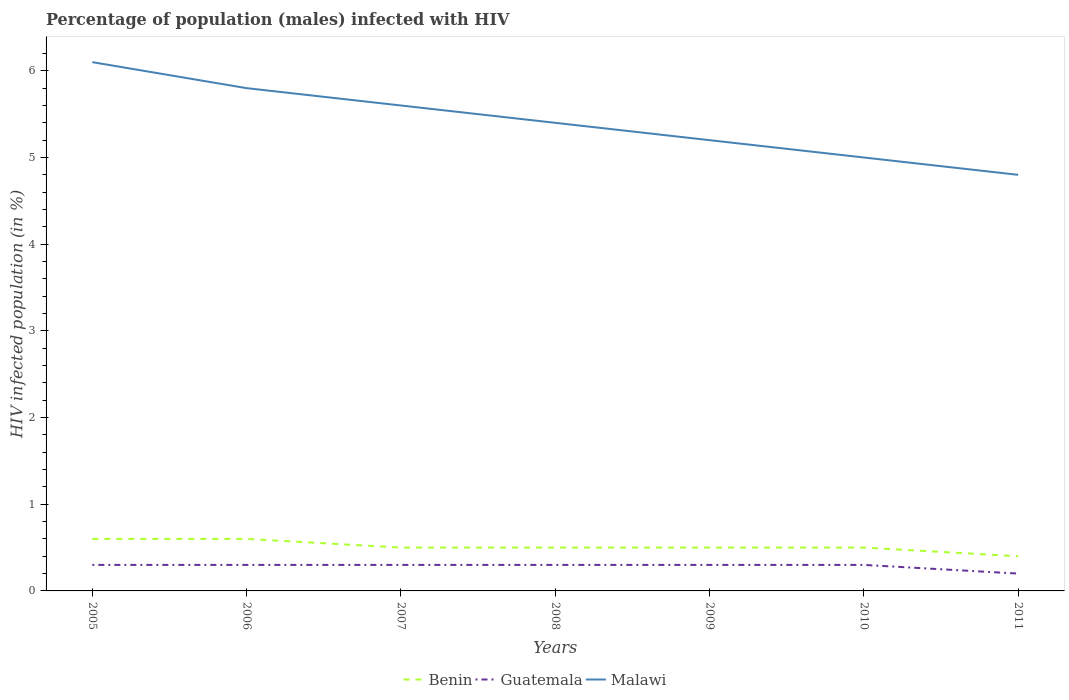How many different coloured lines are there?
Your answer should be very brief. 3. Does the line corresponding to Malawi intersect with the line corresponding to Guatemala?
Your response must be concise. No. Across all years, what is the maximum percentage of HIV infected male population in Malawi?
Keep it short and to the point. 4.8. In which year was the percentage of HIV infected male population in Guatemala maximum?
Provide a short and direct response. 2011. What is the total percentage of HIV infected male population in Benin in the graph?
Your answer should be compact. 0.1. What is the difference between the highest and the second highest percentage of HIV infected male population in Malawi?
Keep it short and to the point. 1.3. How many lines are there?
Keep it short and to the point. 3. How many years are there in the graph?
Your answer should be very brief. 7. How are the legend labels stacked?
Provide a succinct answer. Horizontal. What is the title of the graph?
Make the answer very short. Percentage of population (males) infected with HIV. Does "St. Vincent and the Grenadines" appear as one of the legend labels in the graph?
Provide a short and direct response. No. What is the label or title of the X-axis?
Keep it short and to the point. Years. What is the label or title of the Y-axis?
Give a very brief answer. HIV infected population (in %). What is the HIV infected population (in %) in Benin in 2005?
Offer a terse response. 0.6. What is the HIV infected population (in %) in Guatemala in 2005?
Your response must be concise. 0.3. What is the HIV infected population (in %) of Guatemala in 2006?
Provide a short and direct response. 0.3. What is the HIV infected population (in %) in Malawi in 2006?
Your answer should be compact. 5.8. What is the HIV infected population (in %) of Guatemala in 2007?
Your answer should be very brief. 0.3. What is the HIV infected population (in %) of Guatemala in 2008?
Your answer should be very brief. 0.3. What is the HIV infected population (in %) of Benin in 2009?
Make the answer very short. 0.5. What is the HIV infected population (in %) of Guatemala in 2009?
Make the answer very short. 0.3. What is the HIV infected population (in %) of Malawi in 2009?
Your answer should be very brief. 5.2. What is the HIV infected population (in %) of Benin in 2010?
Keep it short and to the point. 0.5. What is the HIV infected population (in %) in Benin in 2011?
Your answer should be very brief. 0.4. What is the HIV infected population (in %) in Guatemala in 2011?
Provide a succinct answer. 0.2. What is the HIV infected population (in %) in Malawi in 2011?
Offer a terse response. 4.8. Across all years, what is the maximum HIV infected population (in %) of Benin?
Your answer should be very brief. 0.6. Across all years, what is the maximum HIV infected population (in %) of Malawi?
Your answer should be compact. 6.1. Across all years, what is the minimum HIV infected population (in %) in Benin?
Your answer should be very brief. 0.4. Across all years, what is the minimum HIV infected population (in %) in Guatemala?
Offer a very short reply. 0.2. Across all years, what is the minimum HIV infected population (in %) of Malawi?
Your response must be concise. 4.8. What is the total HIV infected population (in %) in Malawi in the graph?
Ensure brevity in your answer.  37.9. What is the difference between the HIV infected population (in %) of Benin in 2005 and that in 2006?
Offer a terse response. 0. What is the difference between the HIV infected population (in %) in Malawi in 2005 and that in 2007?
Your response must be concise. 0.5. What is the difference between the HIV infected population (in %) in Malawi in 2005 and that in 2008?
Make the answer very short. 0.7. What is the difference between the HIV infected population (in %) of Benin in 2005 and that in 2009?
Offer a terse response. 0.1. What is the difference between the HIV infected population (in %) of Guatemala in 2005 and that in 2009?
Your response must be concise. 0. What is the difference between the HIV infected population (in %) in Malawi in 2005 and that in 2009?
Offer a very short reply. 0.9. What is the difference between the HIV infected population (in %) of Malawi in 2005 and that in 2010?
Provide a succinct answer. 1.1. What is the difference between the HIV infected population (in %) of Malawi in 2005 and that in 2011?
Offer a terse response. 1.3. What is the difference between the HIV infected population (in %) in Benin in 2006 and that in 2008?
Keep it short and to the point. 0.1. What is the difference between the HIV infected population (in %) of Guatemala in 2006 and that in 2008?
Give a very brief answer. 0. What is the difference between the HIV infected population (in %) in Malawi in 2006 and that in 2008?
Your response must be concise. 0.4. What is the difference between the HIV infected population (in %) of Benin in 2006 and that in 2009?
Provide a succinct answer. 0.1. What is the difference between the HIV infected population (in %) in Guatemala in 2006 and that in 2009?
Offer a terse response. 0. What is the difference between the HIV infected population (in %) of Malawi in 2006 and that in 2009?
Make the answer very short. 0.6. What is the difference between the HIV infected population (in %) in Benin in 2006 and that in 2010?
Give a very brief answer. 0.1. What is the difference between the HIV infected population (in %) in Guatemala in 2006 and that in 2010?
Your answer should be compact. 0. What is the difference between the HIV infected population (in %) in Malawi in 2006 and that in 2010?
Offer a terse response. 0.8. What is the difference between the HIV infected population (in %) in Benin in 2006 and that in 2011?
Your response must be concise. 0.2. What is the difference between the HIV infected population (in %) in Guatemala in 2006 and that in 2011?
Make the answer very short. 0.1. What is the difference between the HIV infected population (in %) of Benin in 2007 and that in 2008?
Your answer should be compact. 0. What is the difference between the HIV infected population (in %) of Malawi in 2007 and that in 2008?
Keep it short and to the point. 0.2. What is the difference between the HIV infected population (in %) of Benin in 2007 and that in 2009?
Ensure brevity in your answer.  0. What is the difference between the HIV infected population (in %) of Malawi in 2007 and that in 2009?
Provide a short and direct response. 0.4. What is the difference between the HIV infected population (in %) in Malawi in 2007 and that in 2010?
Provide a short and direct response. 0.6. What is the difference between the HIV infected population (in %) of Benin in 2007 and that in 2011?
Keep it short and to the point. 0.1. What is the difference between the HIV infected population (in %) in Malawi in 2007 and that in 2011?
Your answer should be very brief. 0.8. What is the difference between the HIV infected population (in %) in Benin in 2008 and that in 2009?
Your response must be concise. 0. What is the difference between the HIV infected population (in %) in Guatemala in 2008 and that in 2009?
Offer a very short reply. 0. What is the difference between the HIV infected population (in %) in Malawi in 2008 and that in 2009?
Give a very brief answer. 0.2. What is the difference between the HIV infected population (in %) of Benin in 2008 and that in 2010?
Your answer should be very brief. 0. What is the difference between the HIV infected population (in %) of Guatemala in 2008 and that in 2010?
Your answer should be very brief. 0. What is the difference between the HIV infected population (in %) in Benin in 2009 and that in 2011?
Your answer should be compact. 0.1. What is the difference between the HIV infected population (in %) in Guatemala in 2009 and that in 2011?
Your response must be concise. 0.1. What is the difference between the HIV infected population (in %) of Malawi in 2010 and that in 2011?
Offer a very short reply. 0.2. What is the difference between the HIV infected population (in %) of Guatemala in 2005 and the HIV infected population (in %) of Malawi in 2006?
Offer a terse response. -5.5. What is the difference between the HIV infected population (in %) of Guatemala in 2005 and the HIV infected population (in %) of Malawi in 2007?
Ensure brevity in your answer.  -5.3. What is the difference between the HIV infected population (in %) in Guatemala in 2005 and the HIV infected population (in %) in Malawi in 2008?
Give a very brief answer. -5.1. What is the difference between the HIV infected population (in %) in Benin in 2005 and the HIV infected population (in %) in Guatemala in 2009?
Provide a short and direct response. 0.3. What is the difference between the HIV infected population (in %) of Benin in 2005 and the HIV infected population (in %) of Malawi in 2009?
Your response must be concise. -4.6. What is the difference between the HIV infected population (in %) in Benin in 2005 and the HIV infected population (in %) in Guatemala in 2010?
Your answer should be very brief. 0.3. What is the difference between the HIV infected population (in %) in Guatemala in 2005 and the HIV infected population (in %) in Malawi in 2010?
Your response must be concise. -4.7. What is the difference between the HIV infected population (in %) in Benin in 2006 and the HIV infected population (in %) in Guatemala in 2007?
Offer a very short reply. 0.3. What is the difference between the HIV infected population (in %) of Benin in 2006 and the HIV infected population (in %) of Malawi in 2007?
Offer a very short reply. -5. What is the difference between the HIV infected population (in %) of Guatemala in 2006 and the HIV infected population (in %) of Malawi in 2007?
Ensure brevity in your answer.  -5.3. What is the difference between the HIV infected population (in %) in Benin in 2006 and the HIV infected population (in %) in Guatemala in 2008?
Your response must be concise. 0.3. What is the difference between the HIV infected population (in %) of Benin in 2006 and the HIV infected population (in %) of Guatemala in 2009?
Keep it short and to the point. 0.3. What is the difference between the HIV infected population (in %) of Benin in 2006 and the HIV infected population (in %) of Malawi in 2009?
Provide a succinct answer. -4.6. What is the difference between the HIV infected population (in %) in Guatemala in 2006 and the HIV infected population (in %) in Malawi in 2009?
Provide a short and direct response. -4.9. What is the difference between the HIV infected population (in %) of Benin in 2006 and the HIV infected population (in %) of Guatemala in 2010?
Provide a short and direct response. 0.3. What is the difference between the HIV infected population (in %) in Guatemala in 2006 and the HIV infected population (in %) in Malawi in 2010?
Your answer should be very brief. -4.7. What is the difference between the HIV infected population (in %) of Benin in 2006 and the HIV infected population (in %) of Guatemala in 2011?
Make the answer very short. 0.4. What is the difference between the HIV infected population (in %) of Benin in 2006 and the HIV infected population (in %) of Malawi in 2011?
Your answer should be compact. -4.2. What is the difference between the HIV infected population (in %) of Guatemala in 2006 and the HIV infected population (in %) of Malawi in 2011?
Make the answer very short. -4.5. What is the difference between the HIV infected population (in %) in Benin in 2007 and the HIV infected population (in %) in Guatemala in 2008?
Offer a terse response. 0.2. What is the difference between the HIV infected population (in %) in Benin in 2007 and the HIV infected population (in %) in Malawi in 2008?
Your answer should be compact. -4.9. What is the difference between the HIV infected population (in %) in Guatemala in 2007 and the HIV infected population (in %) in Malawi in 2008?
Provide a succinct answer. -5.1. What is the difference between the HIV infected population (in %) of Benin in 2007 and the HIV infected population (in %) of Guatemala in 2009?
Give a very brief answer. 0.2. What is the difference between the HIV infected population (in %) of Benin in 2007 and the HIV infected population (in %) of Malawi in 2009?
Give a very brief answer. -4.7. What is the difference between the HIV infected population (in %) in Guatemala in 2007 and the HIV infected population (in %) in Malawi in 2009?
Keep it short and to the point. -4.9. What is the difference between the HIV infected population (in %) of Benin in 2007 and the HIV infected population (in %) of Guatemala in 2010?
Keep it short and to the point. 0.2. What is the difference between the HIV infected population (in %) of Benin in 2007 and the HIV infected population (in %) of Malawi in 2010?
Keep it short and to the point. -4.5. What is the difference between the HIV infected population (in %) of Guatemala in 2007 and the HIV infected population (in %) of Malawi in 2010?
Your response must be concise. -4.7. What is the difference between the HIV infected population (in %) of Benin in 2007 and the HIV infected population (in %) of Guatemala in 2011?
Offer a very short reply. 0.3. What is the difference between the HIV infected population (in %) in Benin in 2007 and the HIV infected population (in %) in Malawi in 2011?
Ensure brevity in your answer.  -4.3. What is the difference between the HIV infected population (in %) of Benin in 2008 and the HIV infected population (in %) of Guatemala in 2009?
Provide a short and direct response. 0.2. What is the difference between the HIV infected population (in %) in Guatemala in 2008 and the HIV infected population (in %) in Malawi in 2010?
Offer a terse response. -4.7. What is the difference between the HIV infected population (in %) of Benin in 2008 and the HIV infected population (in %) of Malawi in 2011?
Offer a very short reply. -4.3. What is the difference between the HIV infected population (in %) in Guatemala in 2008 and the HIV infected population (in %) in Malawi in 2011?
Your answer should be very brief. -4.5. What is the difference between the HIV infected population (in %) in Benin in 2009 and the HIV infected population (in %) in Malawi in 2010?
Your answer should be compact. -4.5. What is the difference between the HIV infected population (in %) in Guatemala in 2009 and the HIV infected population (in %) in Malawi in 2010?
Keep it short and to the point. -4.7. What is the difference between the HIV infected population (in %) in Guatemala in 2009 and the HIV infected population (in %) in Malawi in 2011?
Provide a short and direct response. -4.5. What is the difference between the HIV infected population (in %) in Guatemala in 2010 and the HIV infected population (in %) in Malawi in 2011?
Provide a succinct answer. -4.5. What is the average HIV infected population (in %) of Benin per year?
Ensure brevity in your answer.  0.51. What is the average HIV infected population (in %) in Guatemala per year?
Make the answer very short. 0.29. What is the average HIV infected population (in %) of Malawi per year?
Ensure brevity in your answer.  5.41. In the year 2005, what is the difference between the HIV infected population (in %) in Benin and HIV infected population (in %) in Guatemala?
Offer a very short reply. 0.3. In the year 2005, what is the difference between the HIV infected population (in %) in Benin and HIV infected population (in %) in Malawi?
Offer a terse response. -5.5. In the year 2005, what is the difference between the HIV infected population (in %) of Guatemala and HIV infected population (in %) of Malawi?
Provide a short and direct response. -5.8. In the year 2006, what is the difference between the HIV infected population (in %) in Guatemala and HIV infected population (in %) in Malawi?
Offer a terse response. -5.5. In the year 2007, what is the difference between the HIV infected population (in %) in Guatemala and HIV infected population (in %) in Malawi?
Keep it short and to the point. -5.3. In the year 2008, what is the difference between the HIV infected population (in %) of Benin and HIV infected population (in %) of Guatemala?
Your answer should be very brief. 0.2. In the year 2008, what is the difference between the HIV infected population (in %) of Benin and HIV infected population (in %) of Malawi?
Your answer should be very brief. -4.9. In the year 2009, what is the difference between the HIV infected population (in %) in Benin and HIV infected population (in %) in Guatemala?
Provide a succinct answer. 0.2. In the year 2009, what is the difference between the HIV infected population (in %) of Guatemala and HIV infected population (in %) of Malawi?
Give a very brief answer. -4.9. In the year 2011, what is the difference between the HIV infected population (in %) of Benin and HIV infected population (in %) of Malawi?
Offer a terse response. -4.4. What is the ratio of the HIV infected population (in %) in Benin in 2005 to that in 2006?
Offer a very short reply. 1. What is the ratio of the HIV infected population (in %) in Guatemala in 2005 to that in 2006?
Your response must be concise. 1. What is the ratio of the HIV infected population (in %) in Malawi in 2005 to that in 2006?
Provide a short and direct response. 1.05. What is the ratio of the HIV infected population (in %) of Benin in 2005 to that in 2007?
Offer a very short reply. 1.2. What is the ratio of the HIV infected population (in %) in Malawi in 2005 to that in 2007?
Offer a terse response. 1.09. What is the ratio of the HIV infected population (in %) in Malawi in 2005 to that in 2008?
Your answer should be compact. 1.13. What is the ratio of the HIV infected population (in %) in Benin in 2005 to that in 2009?
Your answer should be very brief. 1.2. What is the ratio of the HIV infected population (in %) of Guatemala in 2005 to that in 2009?
Offer a terse response. 1. What is the ratio of the HIV infected population (in %) of Malawi in 2005 to that in 2009?
Give a very brief answer. 1.17. What is the ratio of the HIV infected population (in %) of Guatemala in 2005 to that in 2010?
Your answer should be compact. 1. What is the ratio of the HIV infected population (in %) in Malawi in 2005 to that in 2010?
Keep it short and to the point. 1.22. What is the ratio of the HIV infected population (in %) of Benin in 2005 to that in 2011?
Offer a terse response. 1.5. What is the ratio of the HIV infected population (in %) in Malawi in 2005 to that in 2011?
Provide a short and direct response. 1.27. What is the ratio of the HIV infected population (in %) of Guatemala in 2006 to that in 2007?
Provide a succinct answer. 1. What is the ratio of the HIV infected population (in %) of Malawi in 2006 to that in 2007?
Your response must be concise. 1.04. What is the ratio of the HIV infected population (in %) of Benin in 2006 to that in 2008?
Provide a short and direct response. 1.2. What is the ratio of the HIV infected population (in %) in Guatemala in 2006 to that in 2008?
Offer a very short reply. 1. What is the ratio of the HIV infected population (in %) of Malawi in 2006 to that in 2008?
Provide a succinct answer. 1.07. What is the ratio of the HIV infected population (in %) of Guatemala in 2006 to that in 2009?
Provide a succinct answer. 1. What is the ratio of the HIV infected population (in %) in Malawi in 2006 to that in 2009?
Your answer should be very brief. 1.12. What is the ratio of the HIV infected population (in %) in Benin in 2006 to that in 2010?
Give a very brief answer. 1.2. What is the ratio of the HIV infected population (in %) of Malawi in 2006 to that in 2010?
Offer a very short reply. 1.16. What is the ratio of the HIV infected population (in %) in Benin in 2006 to that in 2011?
Provide a succinct answer. 1.5. What is the ratio of the HIV infected population (in %) of Guatemala in 2006 to that in 2011?
Offer a very short reply. 1.5. What is the ratio of the HIV infected population (in %) of Malawi in 2006 to that in 2011?
Give a very brief answer. 1.21. What is the ratio of the HIV infected population (in %) of Benin in 2007 to that in 2008?
Your answer should be very brief. 1. What is the ratio of the HIV infected population (in %) of Malawi in 2007 to that in 2008?
Offer a terse response. 1.04. What is the ratio of the HIV infected population (in %) of Benin in 2007 to that in 2009?
Offer a very short reply. 1. What is the ratio of the HIV infected population (in %) in Guatemala in 2007 to that in 2009?
Offer a very short reply. 1. What is the ratio of the HIV infected population (in %) in Malawi in 2007 to that in 2009?
Keep it short and to the point. 1.08. What is the ratio of the HIV infected population (in %) in Benin in 2007 to that in 2010?
Your answer should be compact. 1. What is the ratio of the HIV infected population (in %) in Guatemala in 2007 to that in 2010?
Provide a succinct answer. 1. What is the ratio of the HIV infected population (in %) of Malawi in 2007 to that in 2010?
Offer a very short reply. 1.12. What is the ratio of the HIV infected population (in %) in Benin in 2007 to that in 2011?
Your response must be concise. 1.25. What is the ratio of the HIV infected population (in %) in Guatemala in 2007 to that in 2011?
Your answer should be very brief. 1.5. What is the ratio of the HIV infected population (in %) in Benin in 2008 to that in 2009?
Keep it short and to the point. 1. What is the ratio of the HIV infected population (in %) of Guatemala in 2008 to that in 2009?
Offer a terse response. 1. What is the ratio of the HIV infected population (in %) of Benin in 2008 to that in 2010?
Provide a short and direct response. 1. What is the ratio of the HIV infected population (in %) of Guatemala in 2008 to that in 2010?
Provide a succinct answer. 1. What is the ratio of the HIV infected population (in %) in Malawi in 2008 to that in 2010?
Keep it short and to the point. 1.08. What is the ratio of the HIV infected population (in %) in Guatemala in 2008 to that in 2011?
Offer a terse response. 1.5. What is the ratio of the HIV infected population (in %) of Malawi in 2008 to that in 2011?
Make the answer very short. 1.12. What is the ratio of the HIV infected population (in %) of Malawi in 2009 to that in 2011?
Provide a succinct answer. 1.08. What is the ratio of the HIV infected population (in %) in Benin in 2010 to that in 2011?
Make the answer very short. 1.25. What is the ratio of the HIV infected population (in %) in Guatemala in 2010 to that in 2011?
Make the answer very short. 1.5. What is the ratio of the HIV infected population (in %) of Malawi in 2010 to that in 2011?
Provide a succinct answer. 1.04. What is the difference between the highest and the second highest HIV infected population (in %) in Benin?
Provide a succinct answer. 0. What is the difference between the highest and the second highest HIV infected population (in %) of Guatemala?
Your response must be concise. 0. What is the difference between the highest and the second highest HIV infected population (in %) of Malawi?
Your answer should be compact. 0.3. What is the difference between the highest and the lowest HIV infected population (in %) in Benin?
Your answer should be compact. 0.2. What is the difference between the highest and the lowest HIV infected population (in %) in Malawi?
Your answer should be compact. 1.3. 